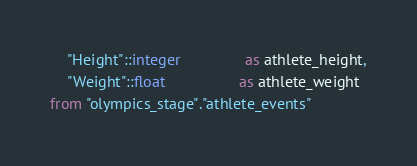<code> <loc_0><loc_0><loc_500><loc_500><_SQL_>    "Height"::integer               as athlete_height,
    "Weight"::float                 as athlete_weight
from "olympics_stage"."athlete_events"
</code> 